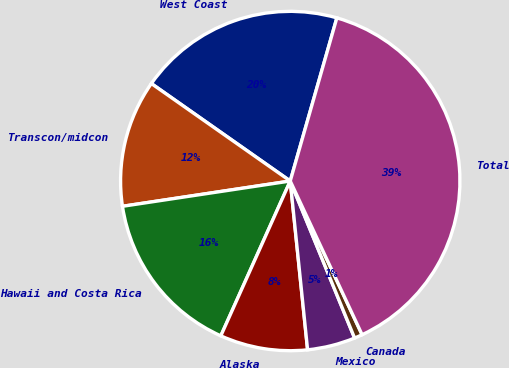<chart> <loc_0><loc_0><loc_500><loc_500><pie_chart><fcel>West Coast<fcel>Transcon/midcon<fcel>Hawaii and Costa Rica<fcel>Alaska<fcel>Mexico<fcel>Canada<fcel>Total<nl><fcel>19.69%<fcel>12.12%<fcel>15.91%<fcel>8.34%<fcel>4.56%<fcel>0.77%<fcel>38.61%<nl></chart> 